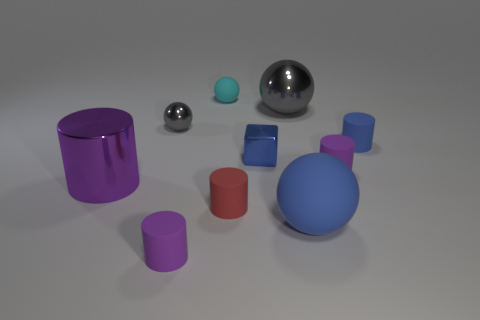Subtract all large cylinders. How many cylinders are left? 4 Subtract all cyan balls. How many purple cylinders are left? 3 Subtract all blue balls. How many balls are left? 3 Subtract all purple spheres. Subtract all gray cylinders. How many spheres are left? 4 Subtract all balls. How many objects are left? 6 Subtract all purple cylinders. Subtract all tiny blue matte cylinders. How many objects are left? 6 Add 8 cyan things. How many cyan things are left? 9 Add 3 gray metal objects. How many gray metal objects exist? 5 Subtract 0 yellow cylinders. How many objects are left? 10 